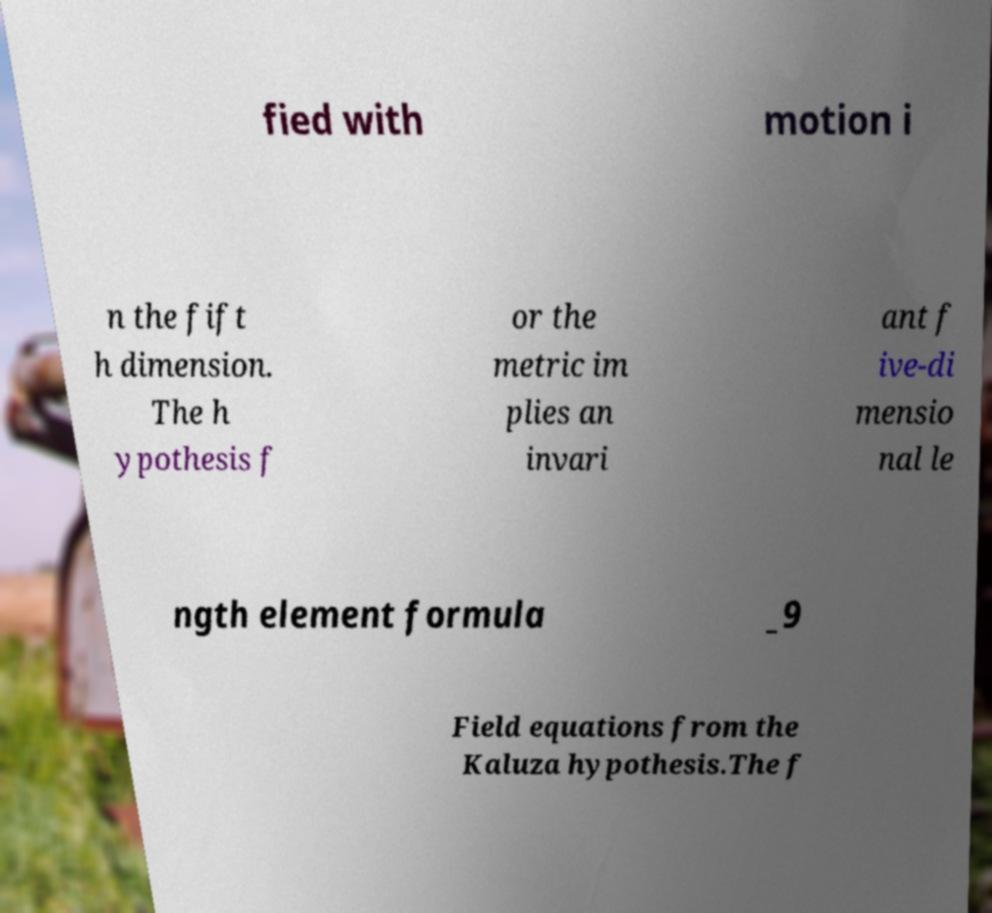I need the written content from this picture converted into text. Can you do that? fied with motion i n the fift h dimension. The h ypothesis f or the metric im plies an invari ant f ive-di mensio nal le ngth element formula _9 Field equations from the Kaluza hypothesis.The f 